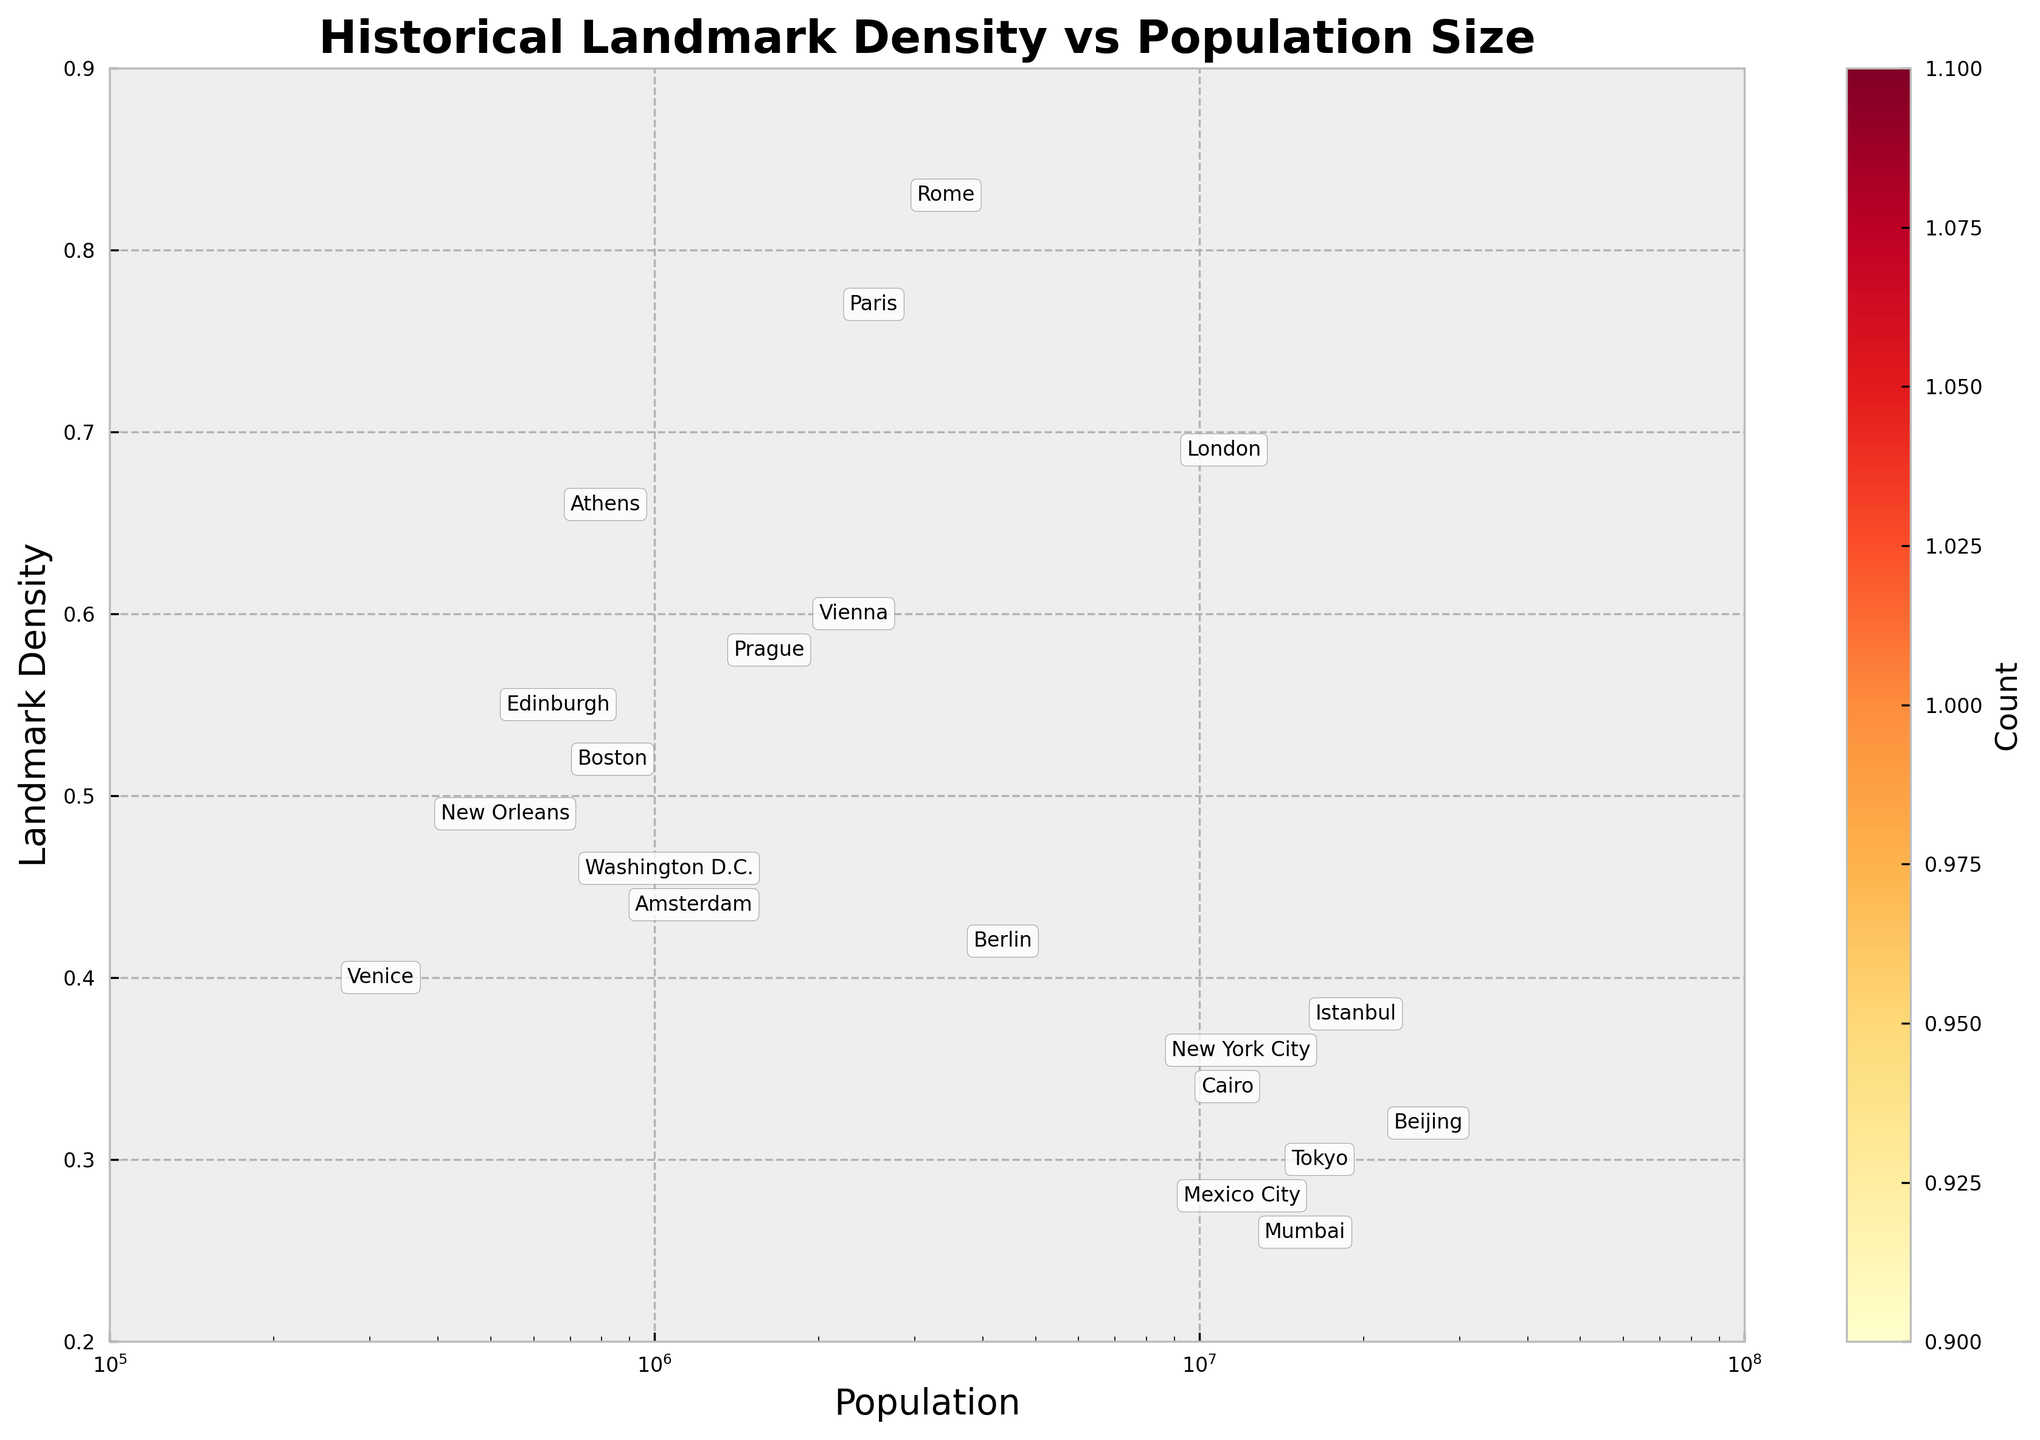How many cities are shown in the plot? There are 20 rows in the dataset, and each row corresponds to one city. Therefore, we have 20 cities displayed in the plot.
Answer: 20 What city has the highest landmark density? The city with the highest landmark density value in the provided data is Rome, with a density of 0.82.
Answer: Rome Which city has the largest population size? By looking at the population sizes, Beijing has the largest with a population of 21,542,000.
Answer: Beijing Which city with its population between 1 million and 2 million has the highest landmark density? From the cities in the dataset, Athens, Vienna, and Prague have populations between 1 million and 2 million. Among them, Athens has the highest landmark density of 0.65.
Answer: Athens How does the landmark density of Berlin compare to that of Athens? Berlin's landmark density is 0.41 whereas Athens' is 0.65. Therefore, Athens has a higher landmark density compared to Berlin.
Answer: Athens has a higher density Considering both population and landmark density, which cities fall into the middle range for both? Paris and Vienna are good examples of cities that have moderate values for both population and landmark density based on visual inspection. Paris has a population of around 2.16 million and Vienna around 1.9 million, with densities of 0.76 and 0.59, respectively.
Answer: Paris and Vienna Is there a general trend between population size and landmark density in these cities? There seems to be a slight trend that cities with higher populations generally have lower landmark densities. This can be seen as cities like Beijing and Tokyo have lower landmark densities despite their large populations.
Answer: Larger populations tend to have lower landmark densities What city has nearly half the population of London but a significantly higher landmark density? By comparing the cities, Paris has a population of 2,161,000, which is nearly half of London’s 8,982,000 population. Furthermore, Paris has a landmark density of 0.76, compared to London’s 0.68.
Answer: Paris How does the landmark density change across different cities with populations over 10 million? Considering the data points, Mumbai, Beijing, and Tokyo fall in the category of cities with populations over 10 million. Their landmark densities are 0.25, 0.31, and 0.29, respectively, indicating that these cities generally have lower landmark densities.
Answer: Landmark density is lower in larger cities What can you infer about Washington D.C.’s landmark density compared to other cities with similar populations? Washington D.C. has a population of 705,749 and a landmark density of 0.45. Compared to Boston (population: 684,379, density: 0.51) and Amsterdam (population: 872,680, density: 0.43), Washington D.C. has a moderate landmark density.
Answer: Washington D.C. has a moderate landmark density 